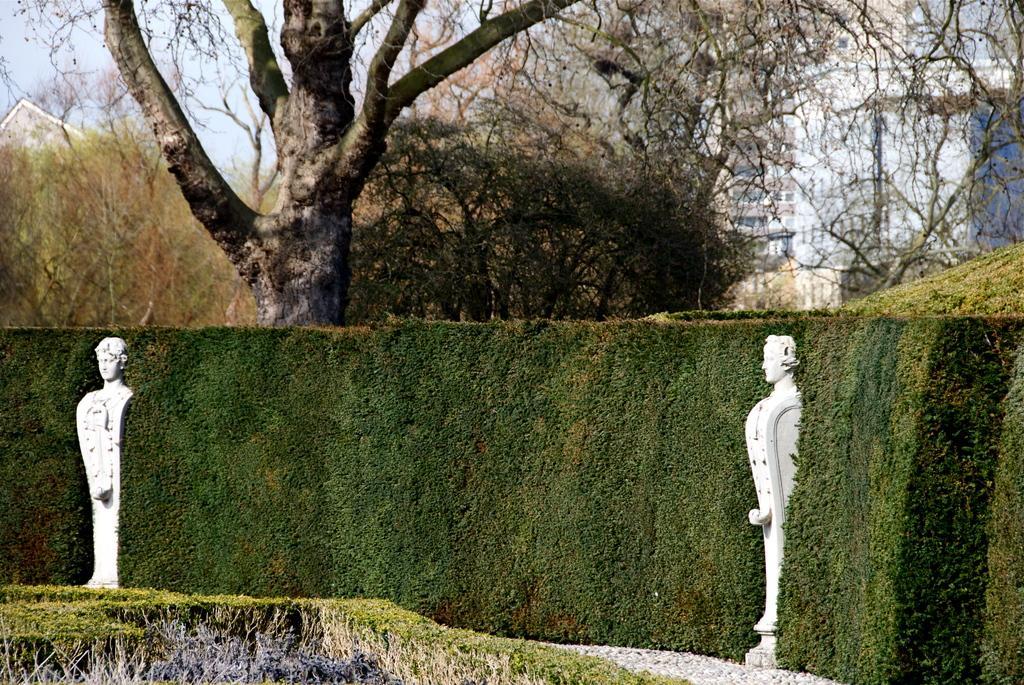Describe this image in one or two sentences. In this picture we can see two statues, grass, trees, buildings and in the background we can see the sky. 